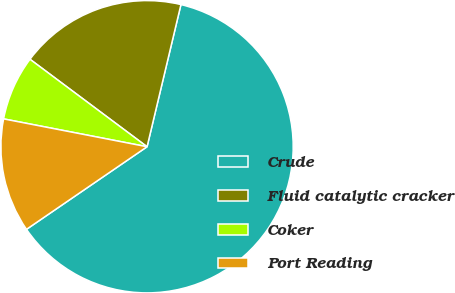<chart> <loc_0><loc_0><loc_500><loc_500><pie_chart><fcel>Crude<fcel>Fluid catalytic cracker<fcel>Coker<fcel>Port Reading<nl><fcel>61.71%<fcel>18.51%<fcel>7.16%<fcel>12.61%<nl></chart> 